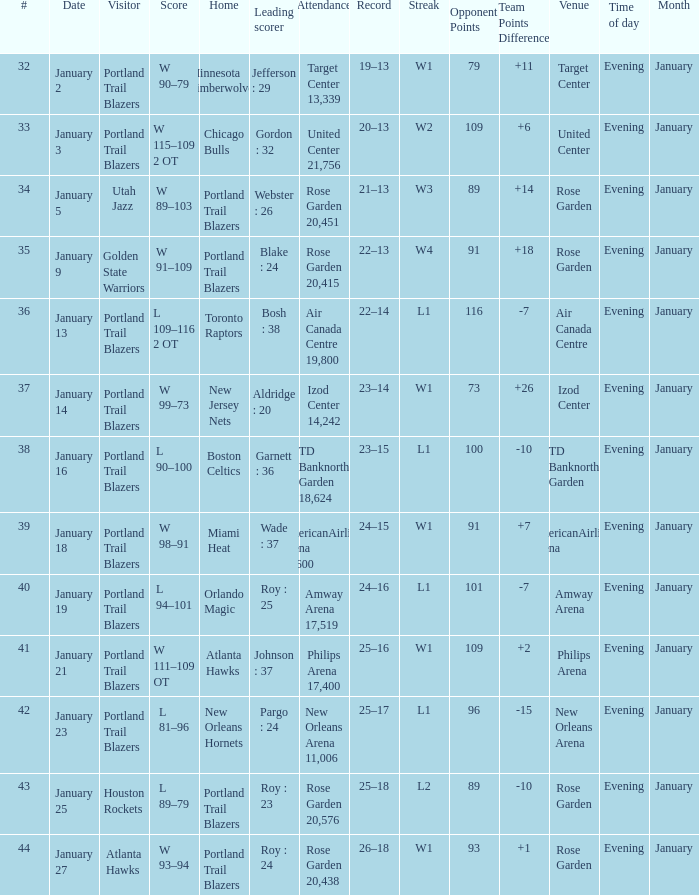Which visitors have a leading scorer of roy : 25 Portland Trail Blazers. 